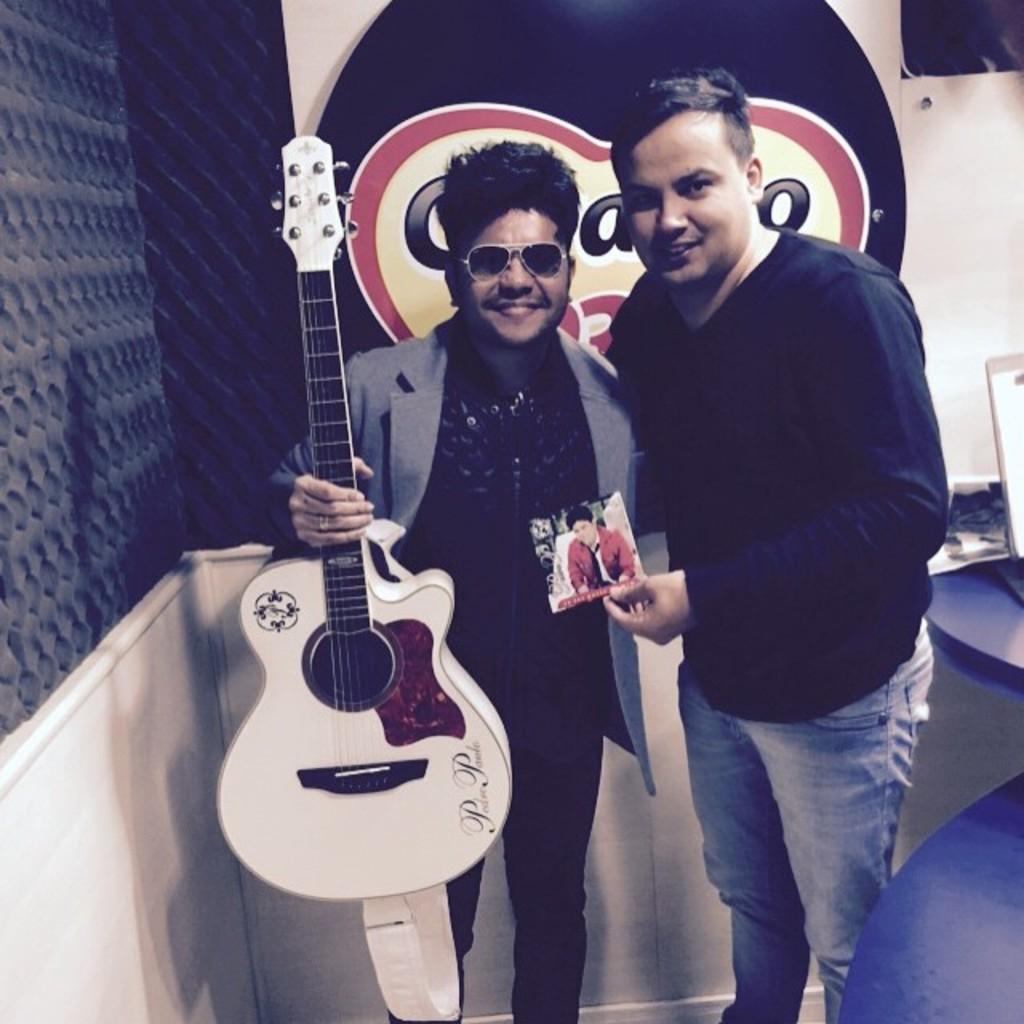Please provide a concise description of this image. In this picture we can see two men where one is holding guitar in his hand and other is holding photo and this man wore blazer, goggle and both are smiling and in background we can see wall with poster beside to him there is table and on table we can see laptop. 